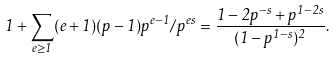Convert formula to latex. <formula><loc_0><loc_0><loc_500><loc_500>1 + \sum _ { e \geq 1 } ( e + 1 ) ( p - 1 ) p ^ { e - 1 } / p ^ { e s } = \frac { 1 - 2 p ^ { - s } + p ^ { 1 - 2 s } } { ( 1 - p ^ { 1 - s } ) ^ { 2 } } .</formula> 